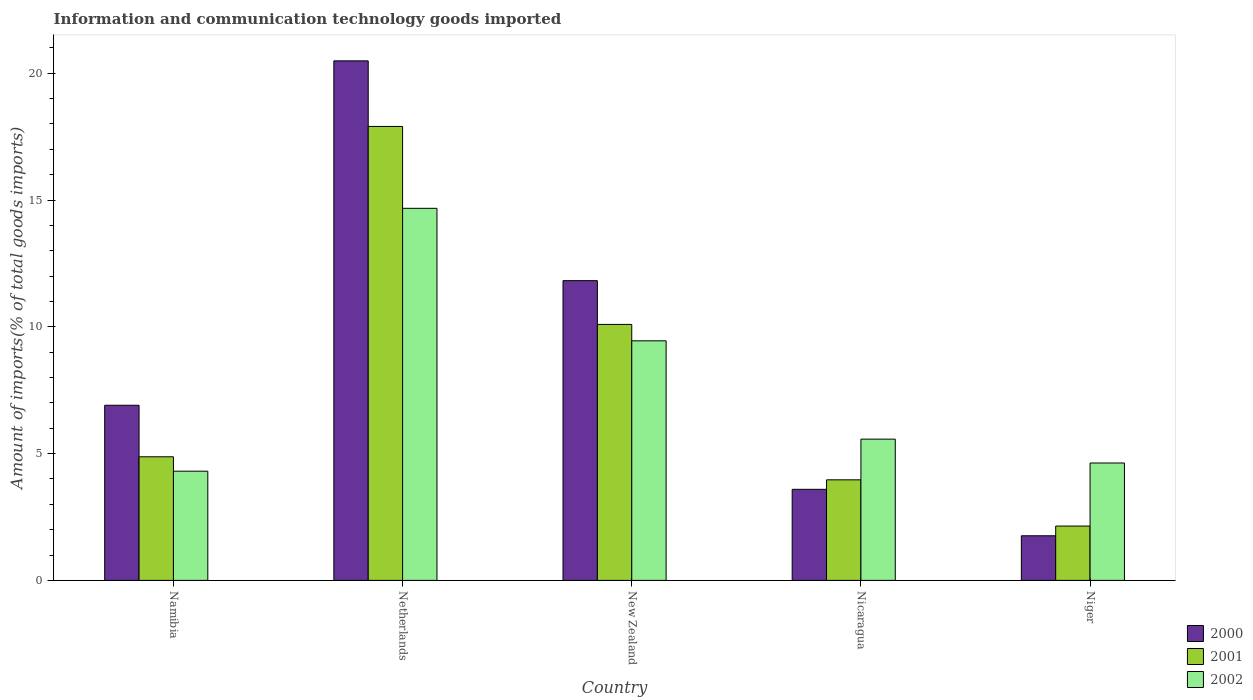How many groups of bars are there?
Your response must be concise. 5. Are the number of bars on each tick of the X-axis equal?
Ensure brevity in your answer.  Yes. How many bars are there on the 2nd tick from the left?
Make the answer very short. 3. How many bars are there on the 2nd tick from the right?
Your answer should be very brief. 3. What is the label of the 4th group of bars from the left?
Give a very brief answer. Nicaragua. In how many cases, is the number of bars for a given country not equal to the number of legend labels?
Provide a succinct answer. 0. What is the amount of goods imported in 2001 in Namibia?
Ensure brevity in your answer.  4.87. Across all countries, what is the maximum amount of goods imported in 2002?
Provide a short and direct response. 14.67. Across all countries, what is the minimum amount of goods imported in 2000?
Provide a succinct answer. 1.76. In which country was the amount of goods imported in 2001 minimum?
Make the answer very short. Niger. What is the total amount of goods imported in 2000 in the graph?
Give a very brief answer. 44.57. What is the difference between the amount of goods imported in 2001 in Nicaragua and that in Niger?
Provide a succinct answer. 1.82. What is the difference between the amount of goods imported in 2002 in Niger and the amount of goods imported in 2001 in Netherlands?
Make the answer very short. -13.27. What is the average amount of goods imported in 2000 per country?
Make the answer very short. 8.91. What is the difference between the amount of goods imported of/in 2002 and amount of goods imported of/in 2001 in Nicaragua?
Your answer should be very brief. 1.6. In how many countries, is the amount of goods imported in 2002 greater than 3 %?
Your answer should be very brief. 5. What is the ratio of the amount of goods imported in 2000 in Nicaragua to that in Niger?
Offer a terse response. 2.04. Is the amount of goods imported in 2001 in New Zealand less than that in Nicaragua?
Your answer should be compact. No. Is the difference between the amount of goods imported in 2002 in Namibia and New Zealand greater than the difference between the amount of goods imported in 2001 in Namibia and New Zealand?
Provide a short and direct response. Yes. What is the difference between the highest and the second highest amount of goods imported in 2002?
Keep it short and to the point. 3.88. What is the difference between the highest and the lowest amount of goods imported in 2002?
Your answer should be compact. 10.37. In how many countries, is the amount of goods imported in 2001 greater than the average amount of goods imported in 2001 taken over all countries?
Your answer should be very brief. 2. Is the sum of the amount of goods imported in 2001 in Netherlands and New Zealand greater than the maximum amount of goods imported in 2000 across all countries?
Make the answer very short. Yes. What does the 3rd bar from the right in New Zealand represents?
Give a very brief answer. 2000. How many bars are there?
Make the answer very short. 15. What is the difference between two consecutive major ticks on the Y-axis?
Offer a terse response. 5. Are the values on the major ticks of Y-axis written in scientific E-notation?
Your answer should be very brief. No. Does the graph contain any zero values?
Make the answer very short. No. What is the title of the graph?
Your answer should be compact. Information and communication technology goods imported. What is the label or title of the X-axis?
Your response must be concise. Country. What is the label or title of the Y-axis?
Make the answer very short. Amount of imports(% of total goods imports). What is the Amount of imports(% of total goods imports) in 2000 in Namibia?
Your answer should be very brief. 6.91. What is the Amount of imports(% of total goods imports) in 2001 in Namibia?
Give a very brief answer. 4.87. What is the Amount of imports(% of total goods imports) in 2002 in Namibia?
Provide a short and direct response. 4.31. What is the Amount of imports(% of total goods imports) in 2000 in Netherlands?
Provide a short and direct response. 20.49. What is the Amount of imports(% of total goods imports) of 2001 in Netherlands?
Provide a succinct answer. 17.9. What is the Amount of imports(% of total goods imports) of 2002 in Netherlands?
Your response must be concise. 14.67. What is the Amount of imports(% of total goods imports) of 2000 in New Zealand?
Your answer should be compact. 11.82. What is the Amount of imports(% of total goods imports) of 2001 in New Zealand?
Offer a very short reply. 10.1. What is the Amount of imports(% of total goods imports) in 2002 in New Zealand?
Give a very brief answer. 9.45. What is the Amount of imports(% of total goods imports) in 2000 in Nicaragua?
Your answer should be very brief. 3.59. What is the Amount of imports(% of total goods imports) in 2001 in Nicaragua?
Make the answer very short. 3.97. What is the Amount of imports(% of total goods imports) of 2002 in Nicaragua?
Your response must be concise. 5.57. What is the Amount of imports(% of total goods imports) in 2000 in Niger?
Give a very brief answer. 1.76. What is the Amount of imports(% of total goods imports) in 2001 in Niger?
Your answer should be very brief. 2.14. What is the Amount of imports(% of total goods imports) in 2002 in Niger?
Make the answer very short. 4.63. Across all countries, what is the maximum Amount of imports(% of total goods imports) of 2000?
Your answer should be very brief. 20.49. Across all countries, what is the maximum Amount of imports(% of total goods imports) in 2001?
Ensure brevity in your answer.  17.9. Across all countries, what is the maximum Amount of imports(% of total goods imports) in 2002?
Offer a very short reply. 14.67. Across all countries, what is the minimum Amount of imports(% of total goods imports) of 2000?
Your response must be concise. 1.76. Across all countries, what is the minimum Amount of imports(% of total goods imports) of 2001?
Offer a very short reply. 2.14. Across all countries, what is the minimum Amount of imports(% of total goods imports) of 2002?
Make the answer very short. 4.31. What is the total Amount of imports(% of total goods imports) in 2000 in the graph?
Your answer should be compact. 44.57. What is the total Amount of imports(% of total goods imports) in 2001 in the graph?
Give a very brief answer. 38.98. What is the total Amount of imports(% of total goods imports) in 2002 in the graph?
Ensure brevity in your answer.  38.63. What is the difference between the Amount of imports(% of total goods imports) of 2000 in Namibia and that in Netherlands?
Provide a succinct answer. -13.58. What is the difference between the Amount of imports(% of total goods imports) of 2001 in Namibia and that in Netherlands?
Keep it short and to the point. -13.03. What is the difference between the Amount of imports(% of total goods imports) of 2002 in Namibia and that in Netherlands?
Your answer should be very brief. -10.37. What is the difference between the Amount of imports(% of total goods imports) in 2000 in Namibia and that in New Zealand?
Give a very brief answer. -4.91. What is the difference between the Amount of imports(% of total goods imports) in 2001 in Namibia and that in New Zealand?
Provide a short and direct response. -5.22. What is the difference between the Amount of imports(% of total goods imports) in 2002 in Namibia and that in New Zealand?
Offer a terse response. -5.14. What is the difference between the Amount of imports(% of total goods imports) in 2000 in Namibia and that in Nicaragua?
Provide a succinct answer. 3.32. What is the difference between the Amount of imports(% of total goods imports) of 2001 in Namibia and that in Nicaragua?
Give a very brief answer. 0.91. What is the difference between the Amount of imports(% of total goods imports) of 2002 in Namibia and that in Nicaragua?
Your answer should be compact. -1.26. What is the difference between the Amount of imports(% of total goods imports) in 2000 in Namibia and that in Niger?
Keep it short and to the point. 5.15. What is the difference between the Amount of imports(% of total goods imports) of 2001 in Namibia and that in Niger?
Keep it short and to the point. 2.73. What is the difference between the Amount of imports(% of total goods imports) of 2002 in Namibia and that in Niger?
Provide a succinct answer. -0.32. What is the difference between the Amount of imports(% of total goods imports) of 2000 in Netherlands and that in New Zealand?
Your response must be concise. 8.67. What is the difference between the Amount of imports(% of total goods imports) of 2001 in Netherlands and that in New Zealand?
Provide a short and direct response. 7.81. What is the difference between the Amount of imports(% of total goods imports) of 2002 in Netherlands and that in New Zealand?
Provide a short and direct response. 5.23. What is the difference between the Amount of imports(% of total goods imports) of 2000 in Netherlands and that in Nicaragua?
Offer a terse response. 16.9. What is the difference between the Amount of imports(% of total goods imports) of 2001 in Netherlands and that in Nicaragua?
Keep it short and to the point. 13.94. What is the difference between the Amount of imports(% of total goods imports) in 2002 in Netherlands and that in Nicaragua?
Your answer should be very brief. 9.1. What is the difference between the Amount of imports(% of total goods imports) of 2000 in Netherlands and that in Niger?
Your answer should be compact. 18.73. What is the difference between the Amount of imports(% of total goods imports) in 2001 in Netherlands and that in Niger?
Make the answer very short. 15.76. What is the difference between the Amount of imports(% of total goods imports) of 2002 in Netherlands and that in Niger?
Keep it short and to the point. 10.04. What is the difference between the Amount of imports(% of total goods imports) of 2000 in New Zealand and that in Nicaragua?
Make the answer very short. 8.23. What is the difference between the Amount of imports(% of total goods imports) of 2001 in New Zealand and that in Nicaragua?
Your answer should be compact. 6.13. What is the difference between the Amount of imports(% of total goods imports) of 2002 in New Zealand and that in Nicaragua?
Offer a terse response. 3.88. What is the difference between the Amount of imports(% of total goods imports) in 2000 in New Zealand and that in Niger?
Offer a very short reply. 10.06. What is the difference between the Amount of imports(% of total goods imports) in 2001 in New Zealand and that in Niger?
Provide a succinct answer. 7.95. What is the difference between the Amount of imports(% of total goods imports) in 2002 in New Zealand and that in Niger?
Keep it short and to the point. 4.82. What is the difference between the Amount of imports(% of total goods imports) in 2000 in Nicaragua and that in Niger?
Give a very brief answer. 1.83. What is the difference between the Amount of imports(% of total goods imports) in 2001 in Nicaragua and that in Niger?
Offer a terse response. 1.82. What is the difference between the Amount of imports(% of total goods imports) of 2002 in Nicaragua and that in Niger?
Provide a short and direct response. 0.94. What is the difference between the Amount of imports(% of total goods imports) in 2000 in Namibia and the Amount of imports(% of total goods imports) in 2001 in Netherlands?
Keep it short and to the point. -11. What is the difference between the Amount of imports(% of total goods imports) in 2000 in Namibia and the Amount of imports(% of total goods imports) in 2002 in Netherlands?
Provide a short and direct response. -7.77. What is the difference between the Amount of imports(% of total goods imports) in 2001 in Namibia and the Amount of imports(% of total goods imports) in 2002 in Netherlands?
Keep it short and to the point. -9.8. What is the difference between the Amount of imports(% of total goods imports) in 2000 in Namibia and the Amount of imports(% of total goods imports) in 2001 in New Zealand?
Provide a short and direct response. -3.19. What is the difference between the Amount of imports(% of total goods imports) in 2000 in Namibia and the Amount of imports(% of total goods imports) in 2002 in New Zealand?
Ensure brevity in your answer.  -2.54. What is the difference between the Amount of imports(% of total goods imports) of 2001 in Namibia and the Amount of imports(% of total goods imports) of 2002 in New Zealand?
Offer a very short reply. -4.57. What is the difference between the Amount of imports(% of total goods imports) in 2000 in Namibia and the Amount of imports(% of total goods imports) in 2001 in Nicaragua?
Ensure brevity in your answer.  2.94. What is the difference between the Amount of imports(% of total goods imports) of 2000 in Namibia and the Amount of imports(% of total goods imports) of 2002 in Nicaragua?
Your response must be concise. 1.34. What is the difference between the Amount of imports(% of total goods imports) in 2001 in Namibia and the Amount of imports(% of total goods imports) in 2002 in Nicaragua?
Provide a succinct answer. -0.7. What is the difference between the Amount of imports(% of total goods imports) of 2000 in Namibia and the Amount of imports(% of total goods imports) of 2001 in Niger?
Provide a succinct answer. 4.76. What is the difference between the Amount of imports(% of total goods imports) of 2000 in Namibia and the Amount of imports(% of total goods imports) of 2002 in Niger?
Offer a very short reply. 2.28. What is the difference between the Amount of imports(% of total goods imports) in 2001 in Namibia and the Amount of imports(% of total goods imports) in 2002 in Niger?
Provide a succinct answer. 0.24. What is the difference between the Amount of imports(% of total goods imports) in 2000 in Netherlands and the Amount of imports(% of total goods imports) in 2001 in New Zealand?
Ensure brevity in your answer.  10.39. What is the difference between the Amount of imports(% of total goods imports) of 2000 in Netherlands and the Amount of imports(% of total goods imports) of 2002 in New Zealand?
Offer a terse response. 11.04. What is the difference between the Amount of imports(% of total goods imports) of 2001 in Netherlands and the Amount of imports(% of total goods imports) of 2002 in New Zealand?
Make the answer very short. 8.46. What is the difference between the Amount of imports(% of total goods imports) of 2000 in Netherlands and the Amount of imports(% of total goods imports) of 2001 in Nicaragua?
Provide a short and direct response. 16.52. What is the difference between the Amount of imports(% of total goods imports) in 2000 in Netherlands and the Amount of imports(% of total goods imports) in 2002 in Nicaragua?
Give a very brief answer. 14.92. What is the difference between the Amount of imports(% of total goods imports) in 2001 in Netherlands and the Amount of imports(% of total goods imports) in 2002 in Nicaragua?
Your answer should be compact. 12.33. What is the difference between the Amount of imports(% of total goods imports) in 2000 in Netherlands and the Amount of imports(% of total goods imports) in 2001 in Niger?
Ensure brevity in your answer.  18.35. What is the difference between the Amount of imports(% of total goods imports) of 2000 in Netherlands and the Amount of imports(% of total goods imports) of 2002 in Niger?
Make the answer very short. 15.86. What is the difference between the Amount of imports(% of total goods imports) of 2001 in Netherlands and the Amount of imports(% of total goods imports) of 2002 in Niger?
Your response must be concise. 13.27. What is the difference between the Amount of imports(% of total goods imports) in 2000 in New Zealand and the Amount of imports(% of total goods imports) in 2001 in Nicaragua?
Ensure brevity in your answer.  7.86. What is the difference between the Amount of imports(% of total goods imports) in 2000 in New Zealand and the Amount of imports(% of total goods imports) in 2002 in Nicaragua?
Provide a succinct answer. 6.25. What is the difference between the Amount of imports(% of total goods imports) of 2001 in New Zealand and the Amount of imports(% of total goods imports) of 2002 in Nicaragua?
Keep it short and to the point. 4.52. What is the difference between the Amount of imports(% of total goods imports) of 2000 in New Zealand and the Amount of imports(% of total goods imports) of 2001 in Niger?
Offer a very short reply. 9.68. What is the difference between the Amount of imports(% of total goods imports) in 2000 in New Zealand and the Amount of imports(% of total goods imports) in 2002 in Niger?
Provide a short and direct response. 7.19. What is the difference between the Amount of imports(% of total goods imports) in 2001 in New Zealand and the Amount of imports(% of total goods imports) in 2002 in Niger?
Ensure brevity in your answer.  5.47. What is the difference between the Amount of imports(% of total goods imports) in 2000 in Nicaragua and the Amount of imports(% of total goods imports) in 2001 in Niger?
Provide a succinct answer. 1.45. What is the difference between the Amount of imports(% of total goods imports) in 2000 in Nicaragua and the Amount of imports(% of total goods imports) in 2002 in Niger?
Ensure brevity in your answer.  -1.04. What is the difference between the Amount of imports(% of total goods imports) in 2001 in Nicaragua and the Amount of imports(% of total goods imports) in 2002 in Niger?
Your response must be concise. -0.66. What is the average Amount of imports(% of total goods imports) in 2000 per country?
Make the answer very short. 8.91. What is the average Amount of imports(% of total goods imports) in 2001 per country?
Offer a terse response. 7.8. What is the average Amount of imports(% of total goods imports) in 2002 per country?
Offer a very short reply. 7.73. What is the difference between the Amount of imports(% of total goods imports) of 2000 and Amount of imports(% of total goods imports) of 2001 in Namibia?
Offer a very short reply. 2.03. What is the difference between the Amount of imports(% of total goods imports) of 2000 and Amount of imports(% of total goods imports) of 2002 in Namibia?
Your answer should be very brief. 2.6. What is the difference between the Amount of imports(% of total goods imports) of 2001 and Amount of imports(% of total goods imports) of 2002 in Namibia?
Your answer should be compact. 0.57. What is the difference between the Amount of imports(% of total goods imports) of 2000 and Amount of imports(% of total goods imports) of 2001 in Netherlands?
Offer a very short reply. 2.59. What is the difference between the Amount of imports(% of total goods imports) in 2000 and Amount of imports(% of total goods imports) in 2002 in Netherlands?
Offer a terse response. 5.82. What is the difference between the Amount of imports(% of total goods imports) of 2001 and Amount of imports(% of total goods imports) of 2002 in Netherlands?
Offer a very short reply. 3.23. What is the difference between the Amount of imports(% of total goods imports) of 2000 and Amount of imports(% of total goods imports) of 2001 in New Zealand?
Your answer should be very brief. 1.73. What is the difference between the Amount of imports(% of total goods imports) of 2000 and Amount of imports(% of total goods imports) of 2002 in New Zealand?
Ensure brevity in your answer.  2.37. What is the difference between the Amount of imports(% of total goods imports) of 2001 and Amount of imports(% of total goods imports) of 2002 in New Zealand?
Your answer should be very brief. 0.65. What is the difference between the Amount of imports(% of total goods imports) in 2000 and Amount of imports(% of total goods imports) in 2001 in Nicaragua?
Offer a terse response. -0.37. What is the difference between the Amount of imports(% of total goods imports) of 2000 and Amount of imports(% of total goods imports) of 2002 in Nicaragua?
Your answer should be very brief. -1.98. What is the difference between the Amount of imports(% of total goods imports) in 2001 and Amount of imports(% of total goods imports) in 2002 in Nicaragua?
Offer a terse response. -1.6. What is the difference between the Amount of imports(% of total goods imports) of 2000 and Amount of imports(% of total goods imports) of 2001 in Niger?
Keep it short and to the point. -0.38. What is the difference between the Amount of imports(% of total goods imports) of 2000 and Amount of imports(% of total goods imports) of 2002 in Niger?
Your answer should be compact. -2.87. What is the difference between the Amount of imports(% of total goods imports) of 2001 and Amount of imports(% of total goods imports) of 2002 in Niger?
Make the answer very short. -2.49. What is the ratio of the Amount of imports(% of total goods imports) in 2000 in Namibia to that in Netherlands?
Your answer should be very brief. 0.34. What is the ratio of the Amount of imports(% of total goods imports) of 2001 in Namibia to that in Netherlands?
Keep it short and to the point. 0.27. What is the ratio of the Amount of imports(% of total goods imports) in 2002 in Namibia to that in Netherlands?
Your answer should be very brief. 0.29. What is the ratio of the Amount of imports(% of total goods imports) in 2000 in Namibia to that in New Zealand?
Make the answer very short. 0.58. What is the ratio of the Amount of imports(% of total goods imports) in 2001 in Namibia to that in New Zealand?
Keep it short and to the point. 0.48. What is the ratio of the Amount of imports(% of total goods imports) in 2002 in Namibia to that in New Zealand?
Your response must be concise. 0.46. What is the ratio of the Amount of imports(% of total goods imports) in 2000 in Namibia to that in Nicaragua?
Your response must be concise. 1.92. What is the ratio of the Amount of imports(% of total goods imports) in 2001 in Namibia to that in Nicaragua?
Your answer should be compact. 1.23. What is the ratio of the Amount of imports(% of total goods imports) of 2002 in Namibia to that in Nicaragua?
Ensure brevity in your answer.  0.77. What is the ratio of the Amount of imports(% of total goods imports) of 2000 in Namibia to that in Niger?
Your answer should be very brief. 3.93. What is the ratio of the Amount of imports(% of total goods imports) of 2001 in Namibia to that in Niger?
Give a very brief answer. 2.27. What is the ratio of the Amount of imports(% of total goods imports) in 2002 in Namibia to that in Niger?
Give a very brief answer. 0.93. What is the ratio of the Amount of imports(% of total goods imports) of 2000 in Netherlands to that in New Zealand?
Provide a succinct answer. 1.73. What is the ratio of the Amount of imports(% of total goods imports) of 2001 in Netherlands to that in New Zealand?
Your answer should be very brief. 1.77. What is the ratio of the Amount of imports(% of total goods imports) of 2002 in Netherlands to that in New Zealand?
Offer a terse response. 1.55. What is the ratio of the Amount of imports(% of total goods imports) in 2000 in Netherlands to that in Nicaragua?
Give a very brief answer. 5.7. What is the ratio of the Amount of imports(% of total goods imports) of 2001 in Netherlands to that in Nicaragua?
Keep it short and to the point. 4.51. What is the ratio of the Amount of imports(% of total goods imports) of 2002 in Netherlands to that in Nicaragua?
Your answer should be very brief. 2.63. What is the ratio of the Amount of imports(% of total goods imports) of 2000 in Netherlands to that in Niger?
Ensure brevity in your answer.  11.64. What is the ratio of the Amount of imports(% of total goods imports) in 2001 in Netherlands to that in Niger?
Your answer should be very brief. 8.35. What is the ratio of the Amount of imports(% of total goods imports) in 2002 in Netherlands to that in Niger?
Your answer should be very brief. 3.17. What is the ratio of the Amount of imports(% of total goods imports) in 2000 in New Zealand to that in Nicaragua?
Offer a very short reply. 3.29. What is the ratio of the Amount of imports(% of total goods imports) in 2001 in New Zealand to that in Nicaragua?
Make the answer very short. 2.55. What is the ratio of the Amount of imports(% of total goods imports) of 2002 in New Zealand to that in Nicaragua?
Provide a succinct answer. 1.7. What is the ratio of the Amount of imports(% of total goods imports) in 2000 in New Zealand to that in Niger?
Make the answer very short. 6.72. What is the ratio of the Amount of imports(% of total goods imports) in 2001 in New Zealand to that in Niger?
Keep it short and to the point. 4.71. What is the ratio of the Amount of imports(% of total goods imports) of 2002 in New Zealand to that in Niger?
Keep it short and to the point. 2.04. What is the ratio of the Amount of imports(% of total goods imports) of 2000 in Nicaragua to that in Niger?
Provide a short and direct response. 2.04. What is the ratio of the Amount of imports(% of total goods imports) in 2001 in Nicaragua to that in Niger?
Offer a terse response. 1.85. What is the ratio of the Amount of imports(% of total goods imports) in 2002 in Nicaragua to that in Niger?
Your response must be concise. 1.2. What is the difference between the highest and the second highest Amount of imports(% of total goods imports) in 2000?
Your answer should be very brief. 8.67. What is the difference between the highest and the second highest Amount of imports(% of total goods imports) of 2001?
Keep it short and to the point. 7.81. What is the difference between the highest and the second highest Amount of imports(% of total goods imports) in 2002?
Give a very brief answer. 5.23. What is the difference between the highest and the lowest Amount of imports(% of total goods imports) of 2000?
Your response must be concise. 18.73. What is the difference between the highest and the lowest Amount of imports(% of total goods imports) in 2001?
Your answer should be very brief. 15.76. What is the difference between the highest and the lowest Amount of imports(% of total goods imports) in 2002?
Ensure brevity in your answer.  10.37. 